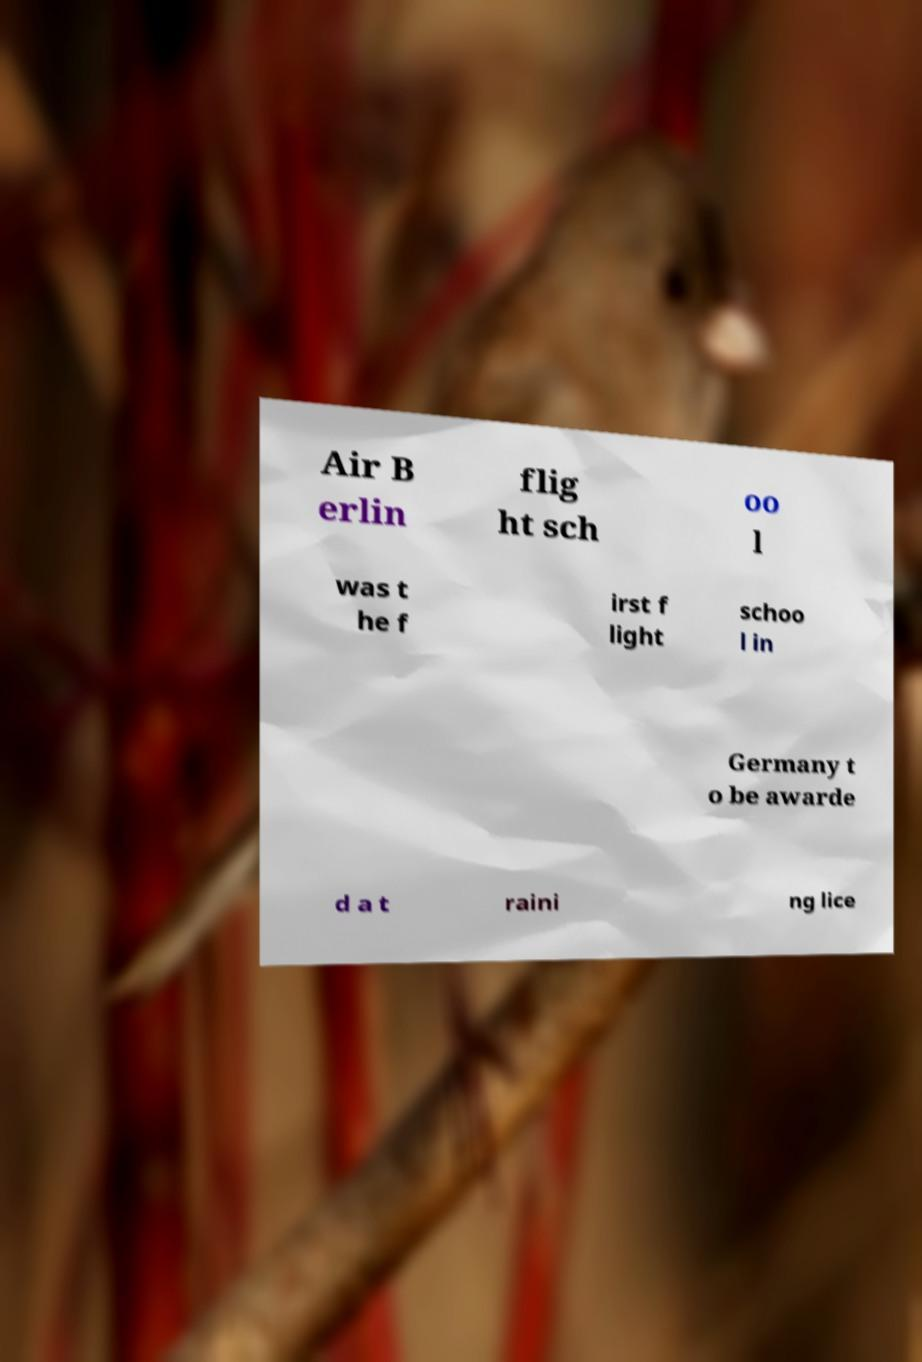For documentation purposes, I need the text within this image transcribed. Could you provide that? Air B erlin flig ht sch oo l was t he f irst f light schoo l in Germany t o be awarde d a t raini ng lice 